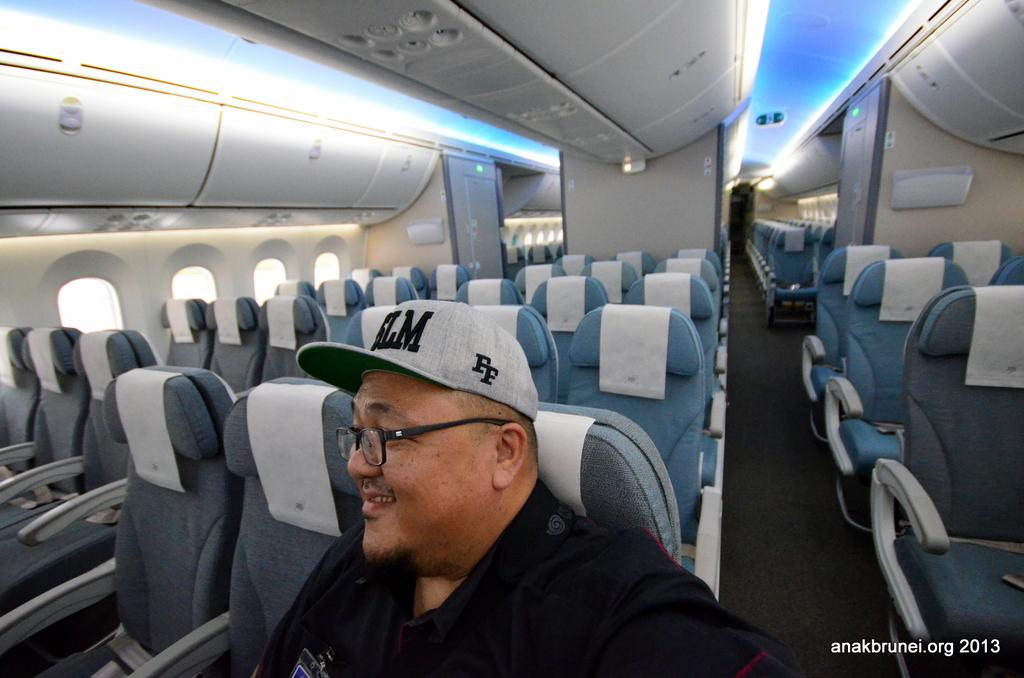<image>
Relay a brief, clear account of the picture shown. Man wearing a cap that says FF on an airplane. 